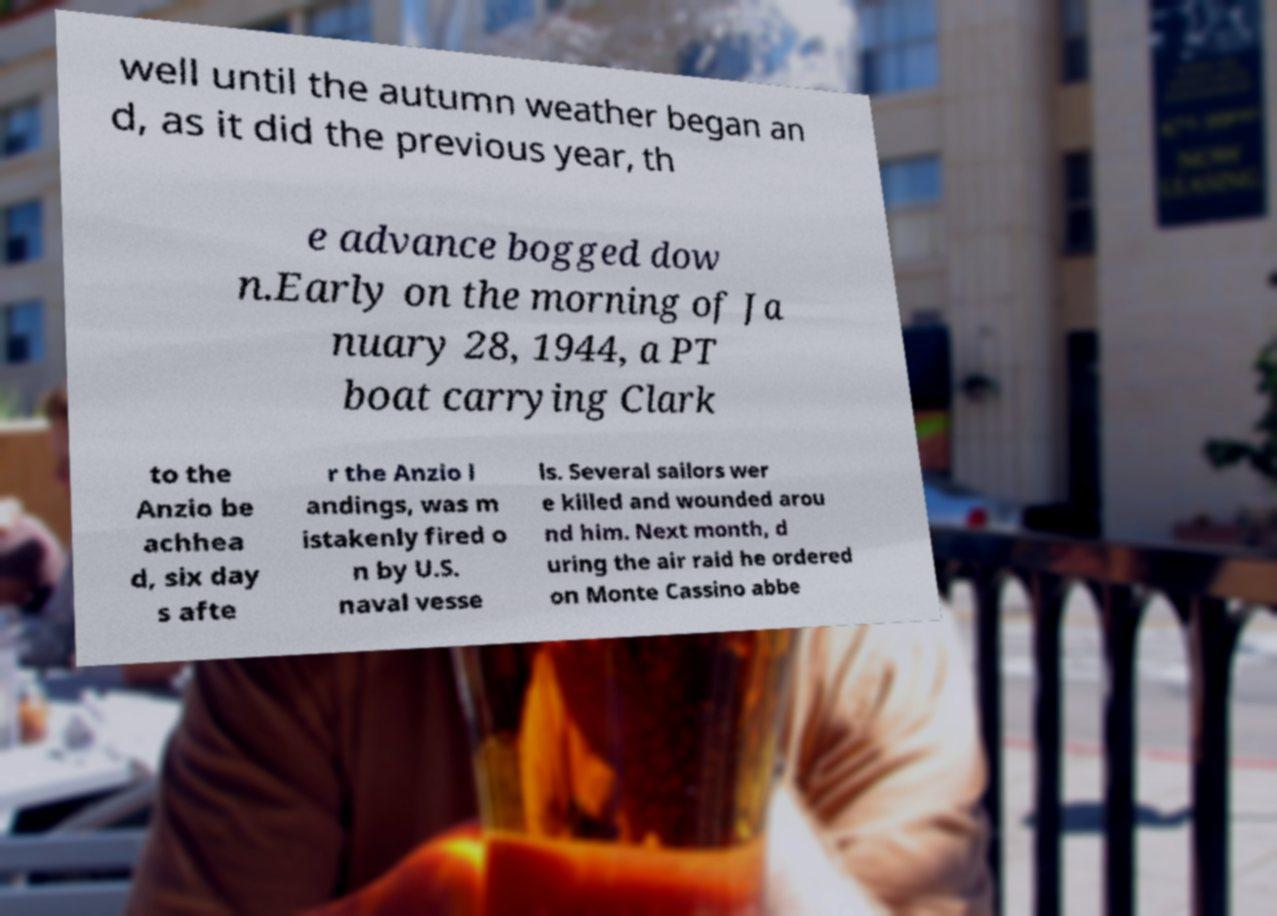I need the written content from this picture converted into text. Can you do that? well until the autumn weather began an d, as it did the previous year, th e advance bogged dow n.Early on the morning of Ja nuary 28, 1944, a PT boat carrying Clark to the Anzio be achhea d, six day s afte r the Anzio l andings, was m istakenly fired o n by U.S. naval vesse ls. Several sailors wer e killed and wounded arou nd him. Next month, d uring the air raid he ordered on Monte Cassino abbe 